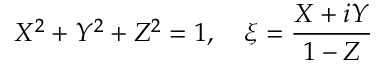Convert formula to latex. <formula><loc_0><loc_0><loc_500><loc_500>X ^ { 2 } + Y ^ { 2 } + Z ^ { 2 } = 1 , \quad \xi = { \frac { X + i Y } { 1 - Z } }</formula> 